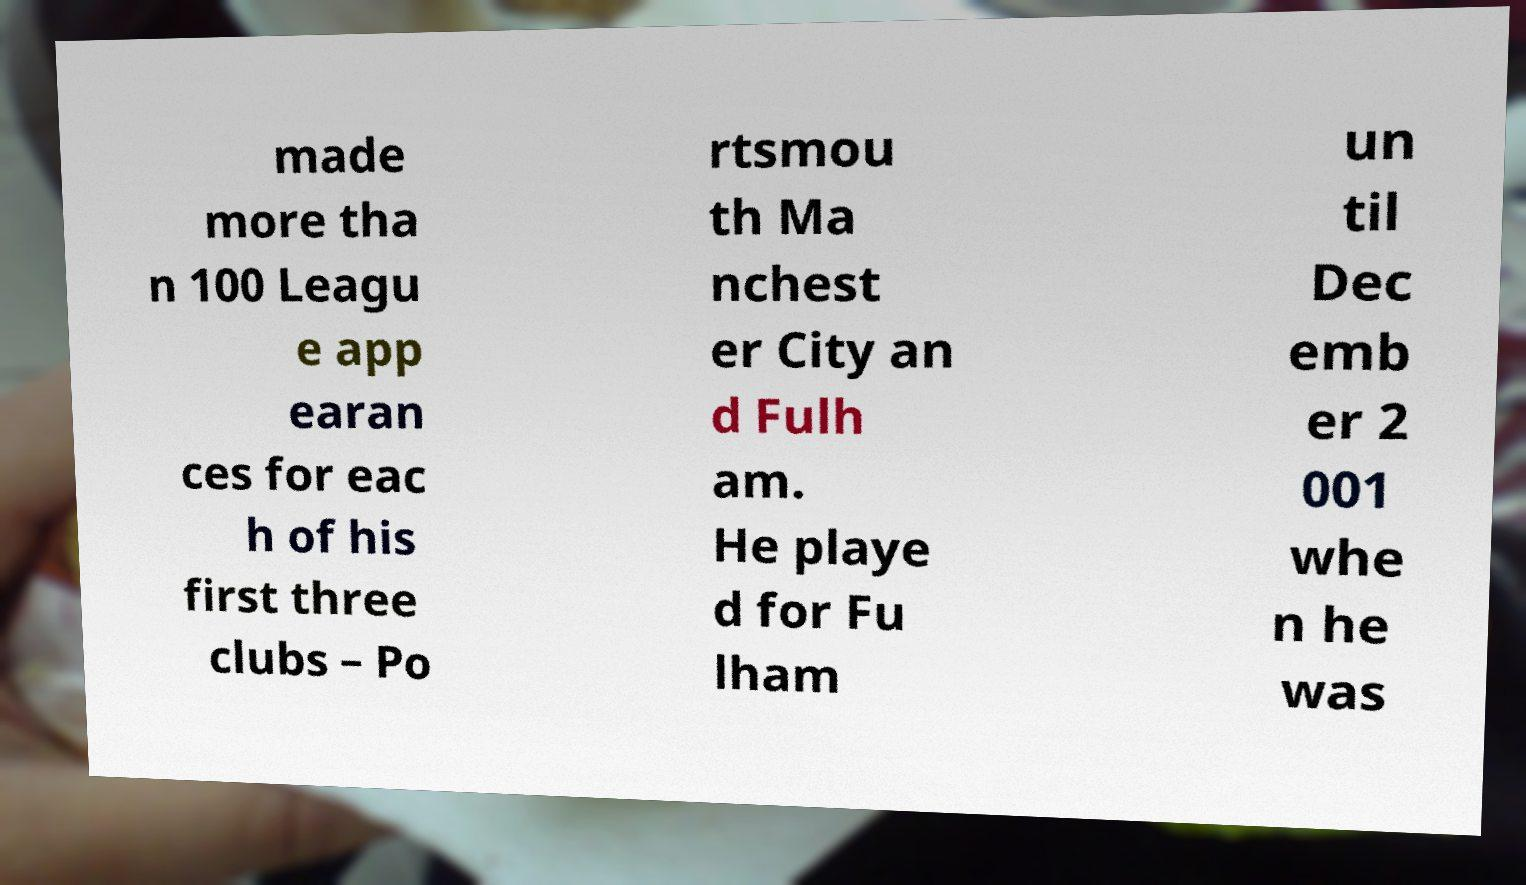There's text embedded in this image that I need extracted. Can you transcribe it verbatim? made more tha n 100 Leagu e app earan ces for eac h of his first three clubs – Po rtsmou th Ma nchest er City an d Fulh am. He playe d for Fu lham un til Dec emb er 2 001 whe n he was 